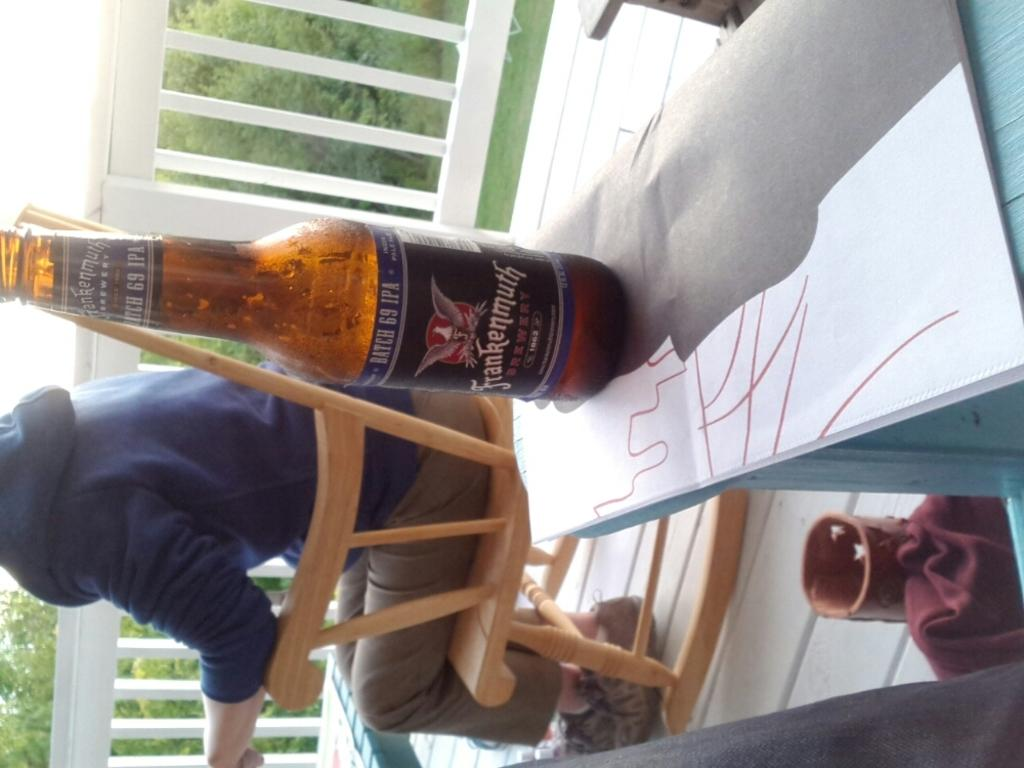<image>
Describe the image concisely. Frankenmuth Brewry Batch 69 IPA witting on top of a table. 